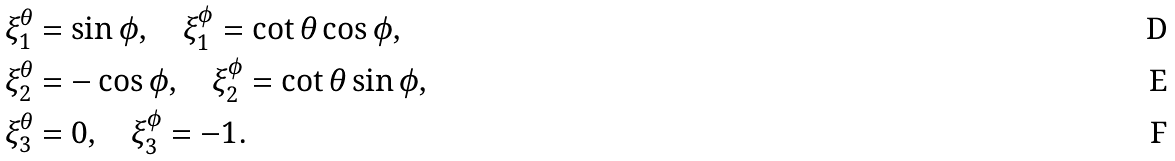Convert formula to latex. <formula><loc_0><loc_0><loc_500><loc_500>\xi _ { 1 } ^ { \theta } & = \sin \phi , \quad \xi _ { 1 } ^ { \phi } = \cot \theta \cos \phi , \\ \xi _ { 2 } ^ { \theta } & = - \cos \phi , \quad \xi _ { 2 } ^ { \phi } = \cot \theta \sin \phi , \\ \xi _ { 3 } ^ { \theta } & = 0 , \quad \xi _ { 3 } ^ { \phi } = - 1 .</formula> 